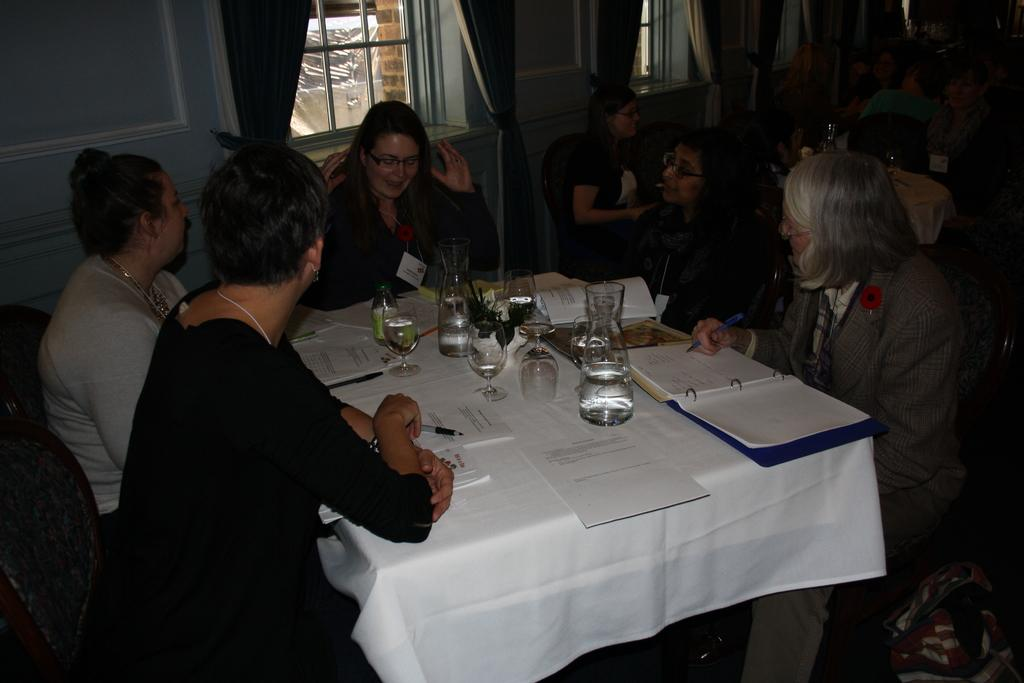How many people are in the image? There is a group of people in the image. What are the people doing in the image? The people are sitting on chairs. Where are the chairs located in relation to the table? The chairs are in front of a table. What can be seen on the table in the image? There are glasses and other objects on the table. How many cats are sitting on the chairs with the people in the image? There are no cats present in the image; only people are sitting on the chairs. 